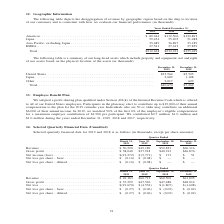According to A10 Networks's financial document, What type of data is shown in the table? Selected quarterly financial data for 2019 and 2018. The document states: "Selected quarterly financial data for 2019 and 2018 is as follows (in thousands, except per share amounts):..." Also, What is the revenue earned in the first quarter of 2019? According to the financial document, $50,290 (in thousands). The relevant text states: "Revenue . $ 50,290 $49,189 $52,833 $60,316 Gross profit . $ 38,040 $37,918 $40,913 $46,876 Net income (loss) . $(12,27..." Also, What is the revenue earned in the second quarter of 2019? According to the financial document, $49,189 (in thousands). The relevant text states: "Revenue . $ 50,290 $49,189 $52,833 $60,316 Gross profit . $ 38,040 $37,918 $40,913 $46,876 Net income (loss) . $(12,272) $ (5,7..." Also, can you calculate: What is the change in revenue between the first and second quarters of 2019? To answer this question, I need to perform calculations using the financial data. The calculation is: ($50,290 - $49,189)/$49,189 , which equals 2.24 (percentage). This is based on the information: "Revenue . $ 50,290 $49,189 $52,833 $60,316 Gross profit . $ 38,040 $37,918 $40,913 $46,876 Net income (loss) . $(12,272) $ (5, Revenue . $ 50,290 $49,189 $52,833 $60,316 Gross profit . $ 38,040 $37,91..." The key data points involved are: 49,189, 50,290. Also, can you calculate: What is the change in gross profit between the second and third quarter of 2018? To answer this question, I need to perform calculations using the financial data. The calculation is: ($47,526 - $47,488)/$47,488 , which equals 0.08 (percentage). This is based on the information: "$60,502 $61,825 Gross profit . $ 37,299 $47,526 $47,488 $48,014 Net loss . $(19,670) $ (4,532) $ (1,807) $ (1,608) Net loss per share - basic . $ (0.27) $ $60,713 $60,502 $61,825 Gross profit . $ 37,2..." The key data points involved are: 47,488, 47,526. Also, can you calculate: What is the difference in revenue between December 31,2018 to December 31,2019? Based on the calculation: $60,316-$61,825, the result is -1509 (in thousands). This is based on the information: "Revenue . $ 49,183 $60,713 $60,502 $61,825 Gross profit . $ 37,299 $47,526 $47,488 $48,014 Net loss . $(19,670) $ (4,532) $ (1,807) $ (1,608) Revenue . $ 50,290 $49,189 $52,833 $60,316 Gross profit . ..." The key data points involved are: 60,316, 61,825. 